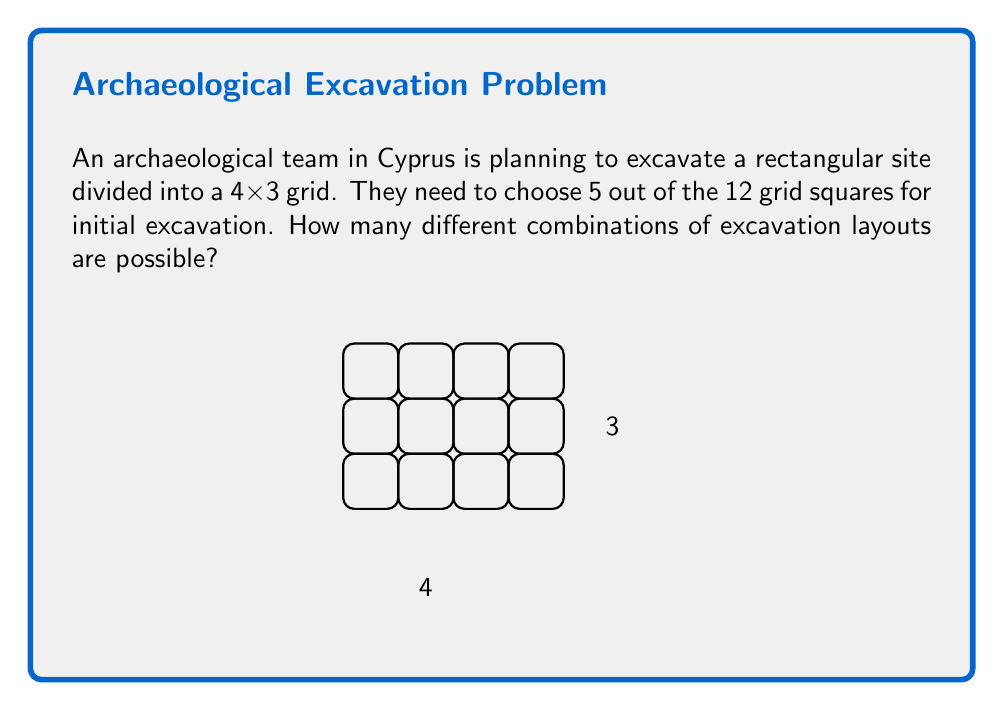Give your solution to this math problem. To solve this problem, we need to use the concept of combinations from combinatorics. Here's the step-by-step solution:

1) We have a total of 12 grid squares (4 x 3 = 12).

2) We need to choose 5 squares out of these 12.

3) The order of selection doesn't matter (choosing squares A, B, C, D, E is the same as choosing B, E, A, C, D).

4) This scenario is perfect for using the combination formula:

   $$C(n,r) = \frac{n!}{r!(n-r)!}$$

   Where $n$ is the total number of items to choose from, and $r$ is the number of items being chosen.

5) In our case, $n = 12$ and $r = 5$

6) Plugging these values into the formula:

   $$C(12,5) = \frac{12!}{5!(12-5)!} = \frac{12!}{5!7!}$$

7) Expanding this:
   
   $$\frac{12 * 11 * 10 * 9 * 8 * 7!}{(5 * 4 * 3 * 2 * 1) * 7!}$$

8) The 7! cancels out in the numerator and denominator:

   $$\frac{12 * 11 * 10 * 9 * 8}{5 * 4 * 3 * 2 * 1} = \frac{95040}{120} = 792$$

Therefore, there are 792 different possible combinations for the excavation layout.
Answer: 792 